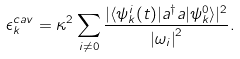<formula> <loc_0><loc_0><loc_500><loc_500>\epsilon _ { k } ^ { c a v } = \kappa ^ { 2 } \sum _ { i \neq 0 } \frac { | \langle \psi _ { k } ^ { i } ( t ) | a ^ { \dagger } a | \psi _ { k } ^ { 0 } \rangle | ^ { 2 } } { \left | \omega _ { i } \right | ^ { 2 } } .</formula> 